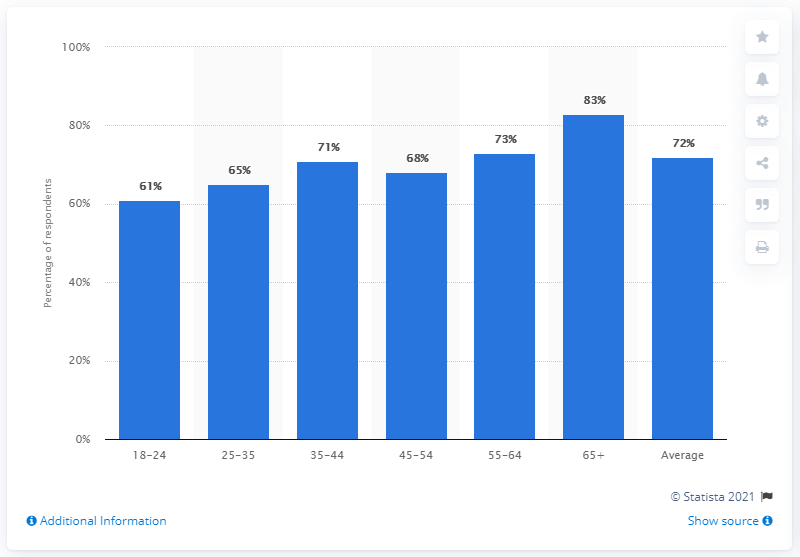Outline some significant characteristics in this image. The 65+ age group is the oldest age group in Great Britain. 